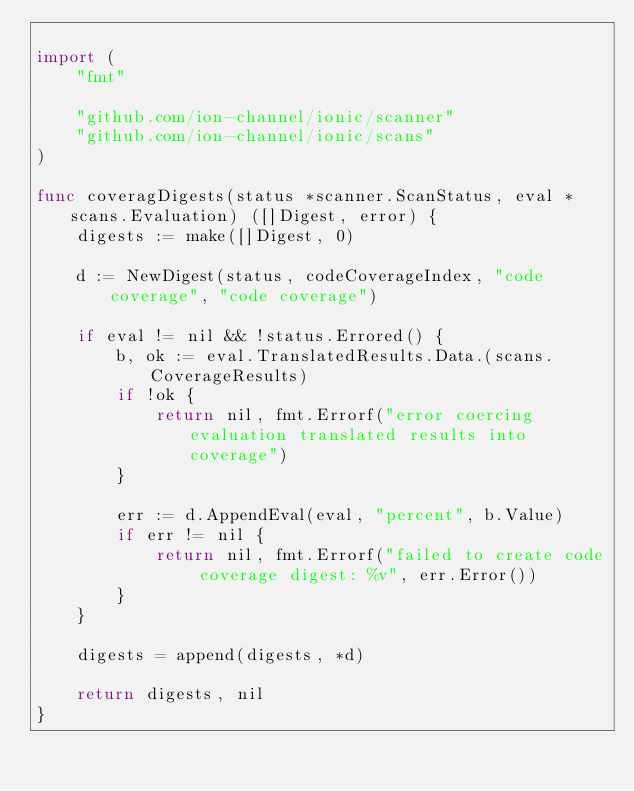Convert code to text. <code><loc_0><loc_0><loc_500><loc_500><_Go_>
import (
	"fmt"

	"github.com/ion-channel/ionic/scanner"
	"github.com/ion-channel/ionic/scans"
)

func coveragDigests(status *scanner.ScanStatus, eval *scans.Evaluation) ([]Digest, error) {
	digests := make([]Digest, 0)

	d := NewDigest(status, codeCoverageIndex, "code coverage", "code coverage")

	if eval != nil && !status.Errored() {
		b, ok := eval.TranslatedResults.Data.(scans.CoverageResults)
		if !ok {
			return nil, fmt.Errorf("error coercing evaluation translated results into coverage")
		}

		err := d.AppendEval(eval, "percent", b.Value)
		if err != nil {
			return nil, fmt.Errorf("failed to create code coverage digest: %v", err.Error())
		}
	}

	digests = append(digests, *d)

	return digests, nil
}
</code> 